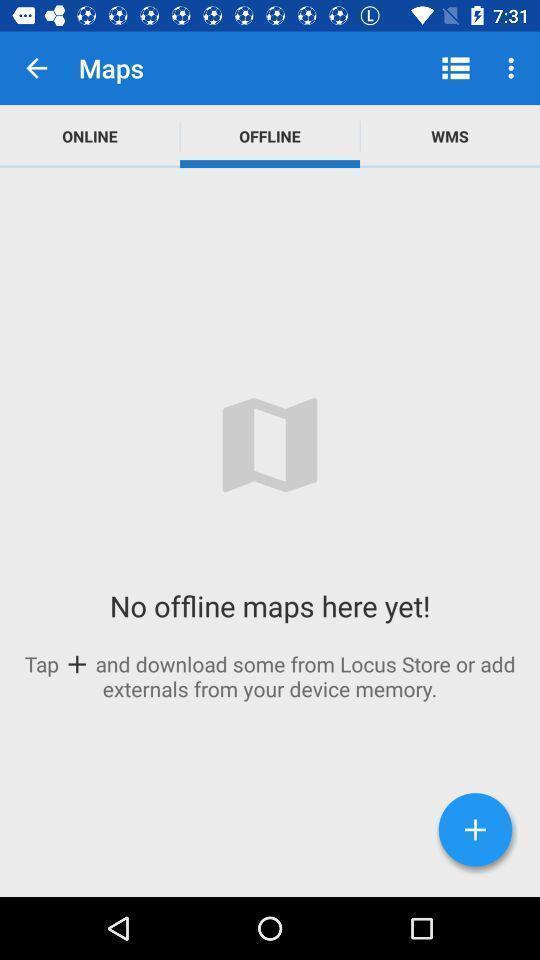Describe this image in words. Screen shows offline maps. 